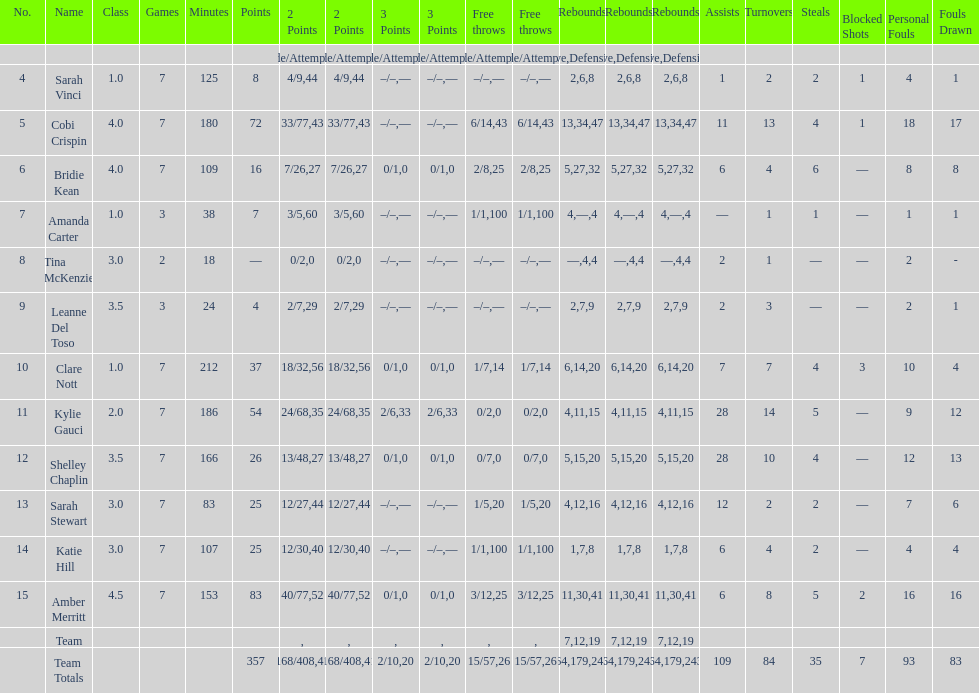Who is the foremost person on the roster to perform less than 20 minutes? Tina McKenzie. 